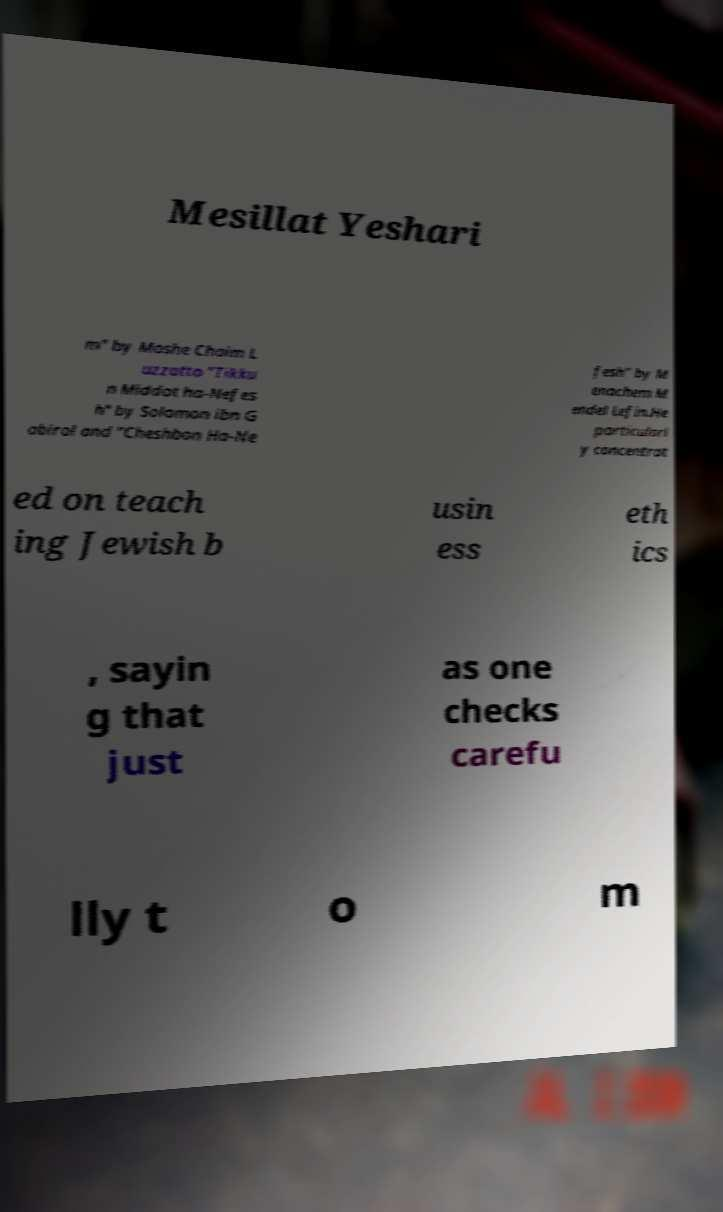Please read and relay the text visible in this image. What does it say? Mesillat Yeshari m" by Moshe Chaim L uzzatto "Tikku n Middot ha-Nefes h" by Solomon ibn G abirol and "Cheshbon Ha-Ne fesh" by M enachem M endel Lefin.He particularl y concentrat ed on teach ing Jewish b usin ess eth ics , sayin g that just as one checks carefu lly t o m 